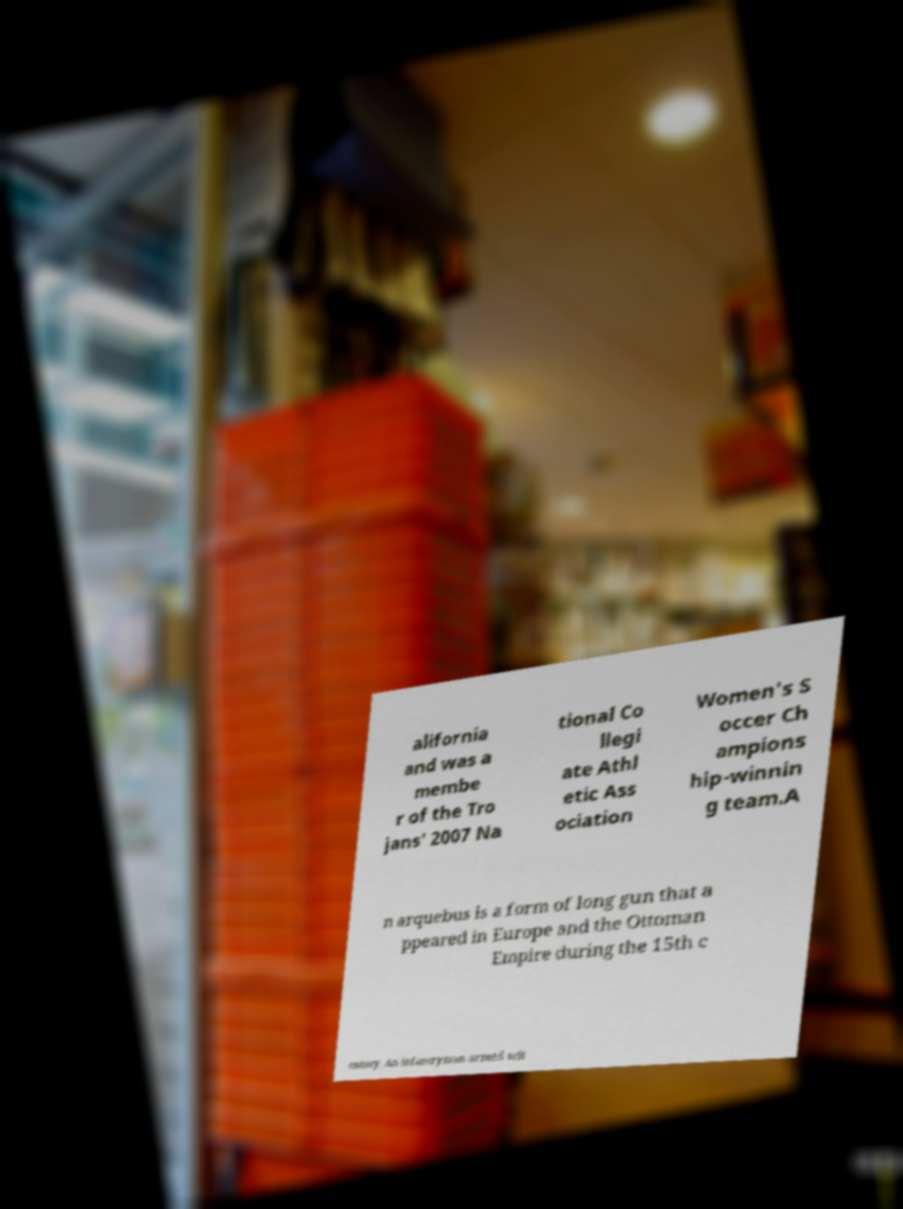Please read and relay the text visible in this image. What does it say? alifornia and was a membe r of the Tro jans' 2007 Na tional Co llegi ate Athl etic Ass ociation Women's S occer Ch ampions hip-winnin g team.A n arquebus is a form of long gun that a ppeared in Europe and the Ottoman Empire during the 15th c entury. An infantryman armed wit 